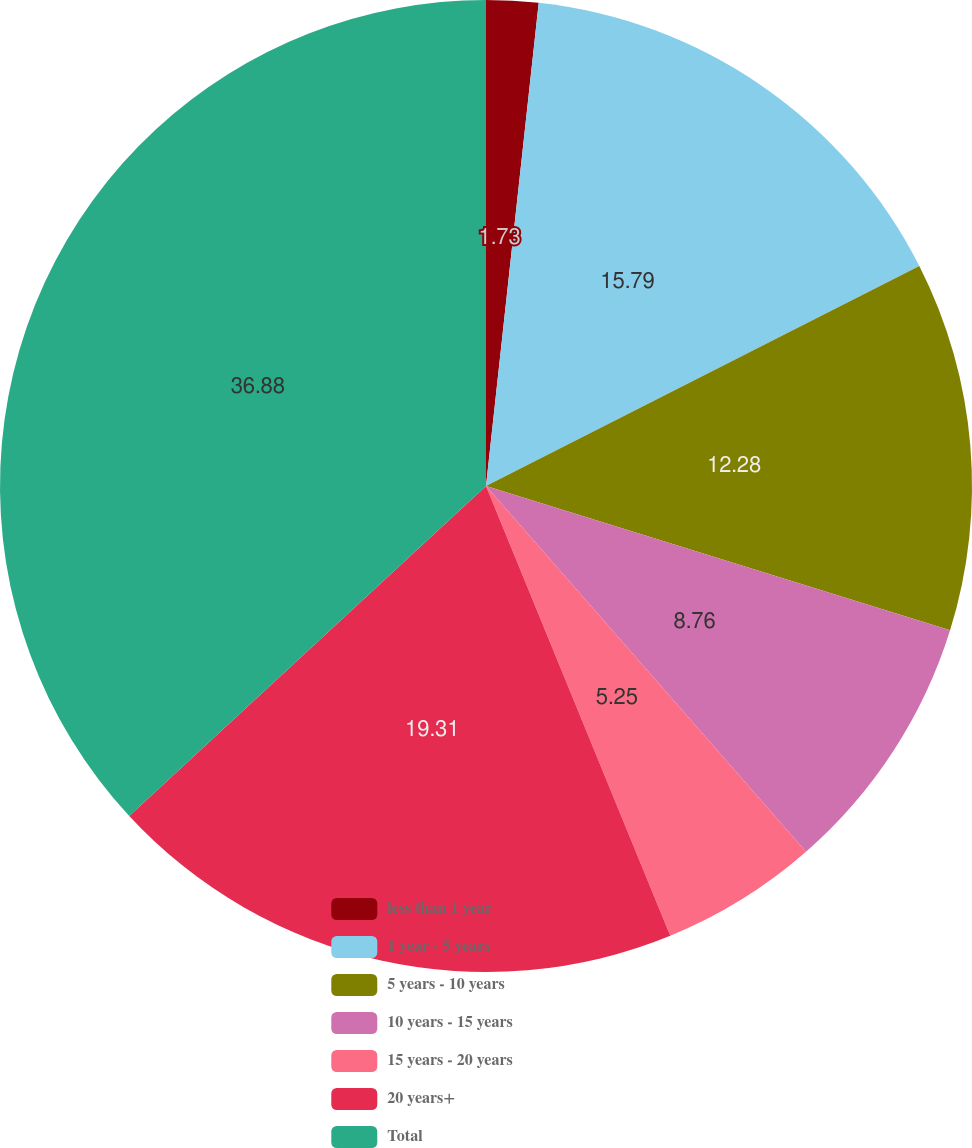Convert chart to OTSL. <chart><loc_0><loc_0><loc_500><loc_500><pie_chart><fcel>less than 1 year<fcel>1 year - 5 years<fcel>5 years - 10 years<fcel>10 years - 15 years<fcel>15 years - 20 years<fcel>20 years+<fcel>Total<nl><fcel>1.73%<fcel>15.79%<fcel>12.28%<fcel>8.76%<fcel>5.25%<fcel>19.31%<fcel>36.88%<nl></chart> 